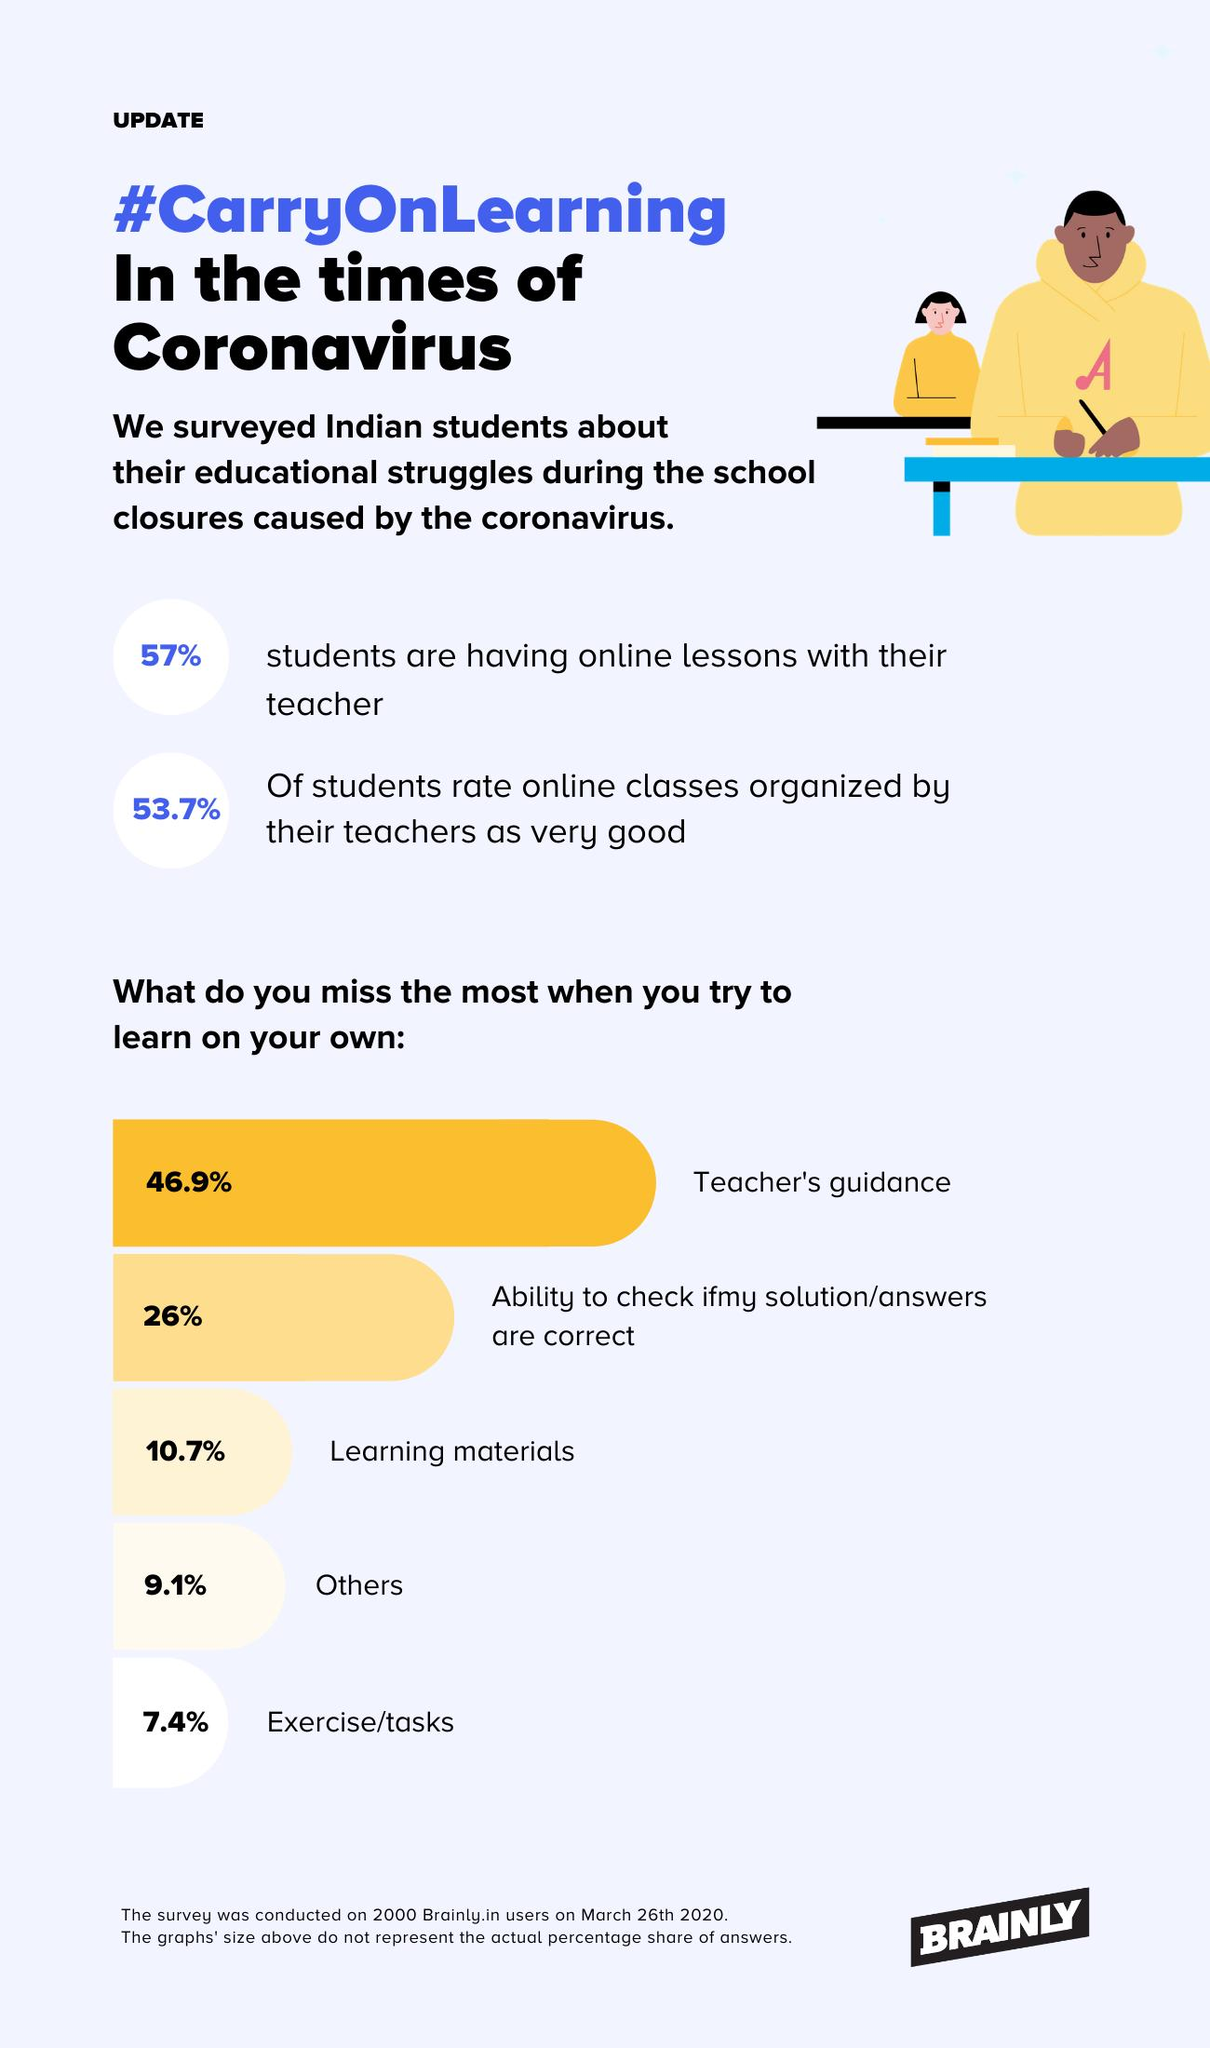Highlight a few significant elements in this photo. According to the data, 43% of students are not having online lessons with their teachers. Eighty-nine point three percent of students did not miss out on learning materials. 53.1% of students did not miss the teacher's guidance. A majority of students, 92.6%, did not miss any tasks. A significant majority of students, 74%, were able to accurately check their answers without missing. 